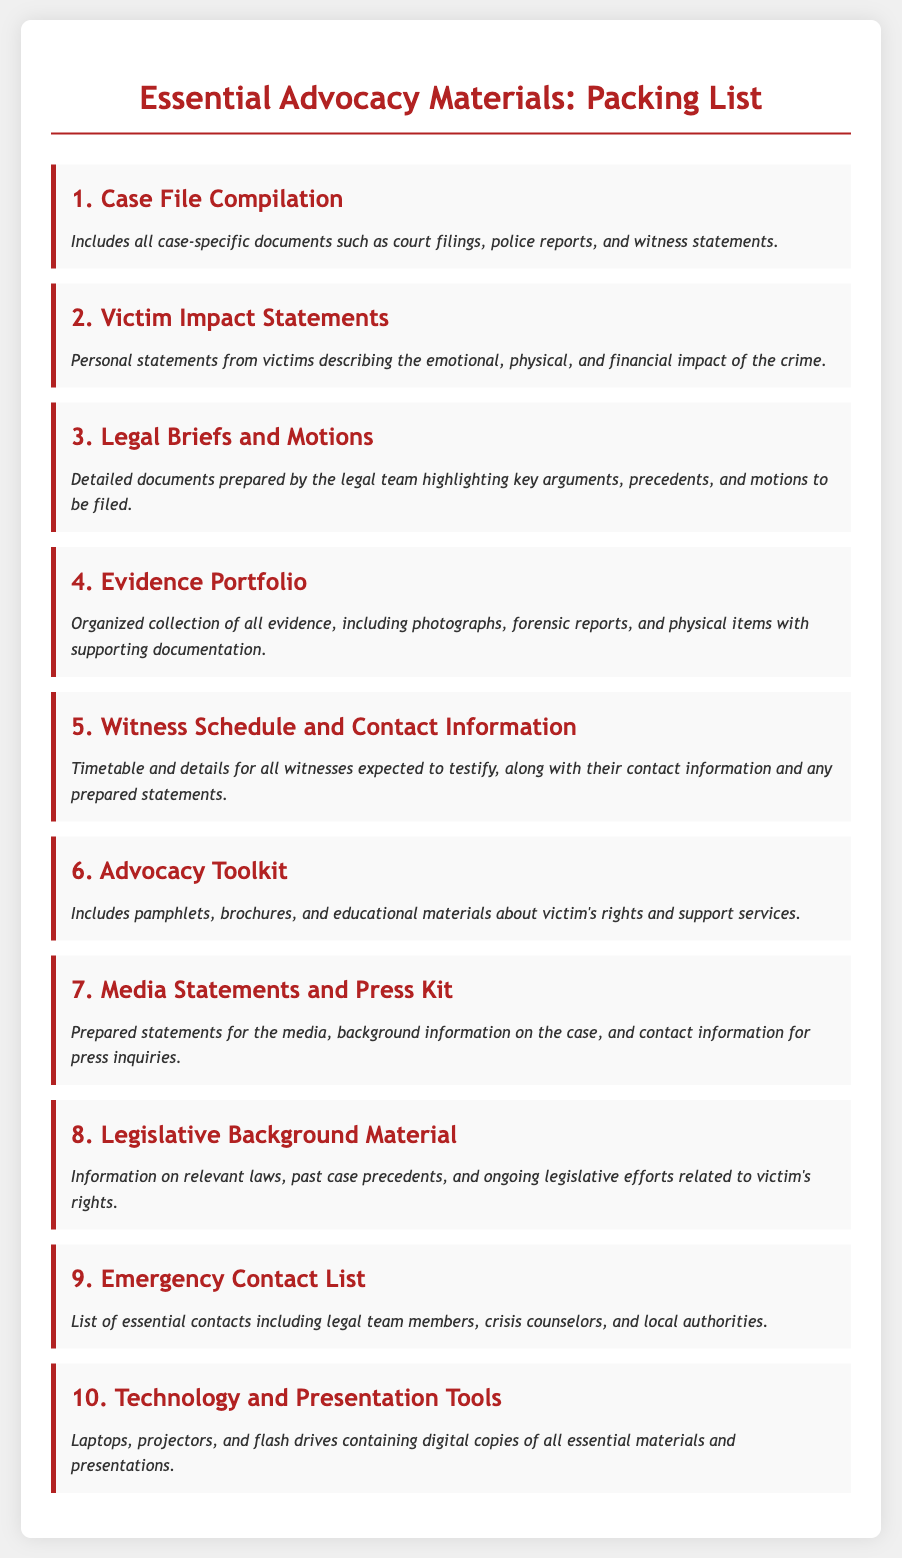What is the first item on the packing list? The first item listed on the packing list is "Case File Compilation."
Answer: Case File Compilation How many items are listed in the packing list? There are a total of ten items mentioned in the packing list.
Answer: 10 What type of statements are included under item 2? Item 2 refers to "Victim Impact Statements," which are personal statements from victims.
Answer: Victim Impact Statements What does the Advocacy Toolkit include? The Advocacy Toolkit includes pamphlets, brochures, and educational materials about victim's rights and support services.
Answer: Pamphlets, brochures, and educational materials What is the purpose of the Media Statements and Press Kit? This kit includes prepared statements for the media and background information on the case.
Answer: Prepared statements for the media Which item corresponds to organized evidence collection? The item detailing organized evidence collection is "Evidence Portfolio."
Answer: Evidence Portfolio What type of tools are mentioned in item 10? Item 10 refers to "Technology and Presentation Tools" such as laptops and projectors.
Answer: Laptops and projectors What is the last item on the packing list? The last item listed in the packing list is "Technology and Presentation Tools."
Answer: Technology and Presentation Tools 